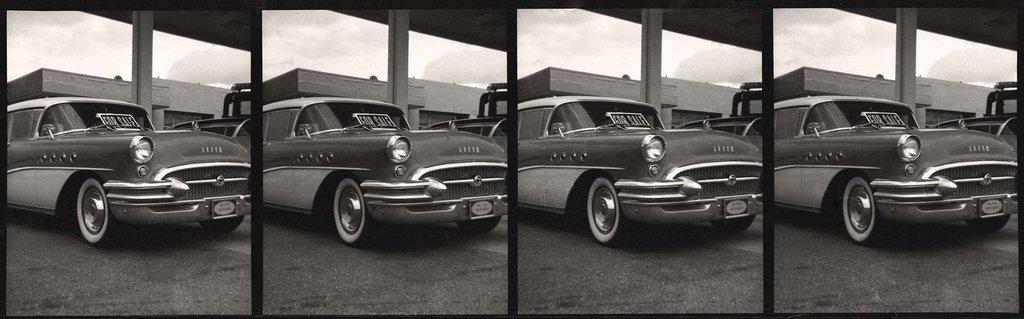Describe this image in one or two sentences. In this image I can see a vehicle, building and the sky. This image is a collage picture. 